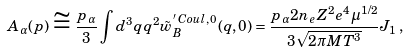<formula> <loc_0><loc_0><loc_500><loc_500>A _ { \alpha } ( { p } ) \cong \frac { p _ { \alpha } } { 3 } \int d ^ { 3 } q q ^ { 2 } \tilde { w } _ { B } ^ { ^ { \prime } \, C o u l , \, 0 } ( { q , 0 } ) = \frac { p _ { \alpha } 2 n _ { e } Z ^ { 2 } e ^ { 4 } \mu ^ { 1 / 2 } } { 3 \sqrt { 2 \pi M T ^ { 3 } } } J _ { 1 } \, ,</formula> 